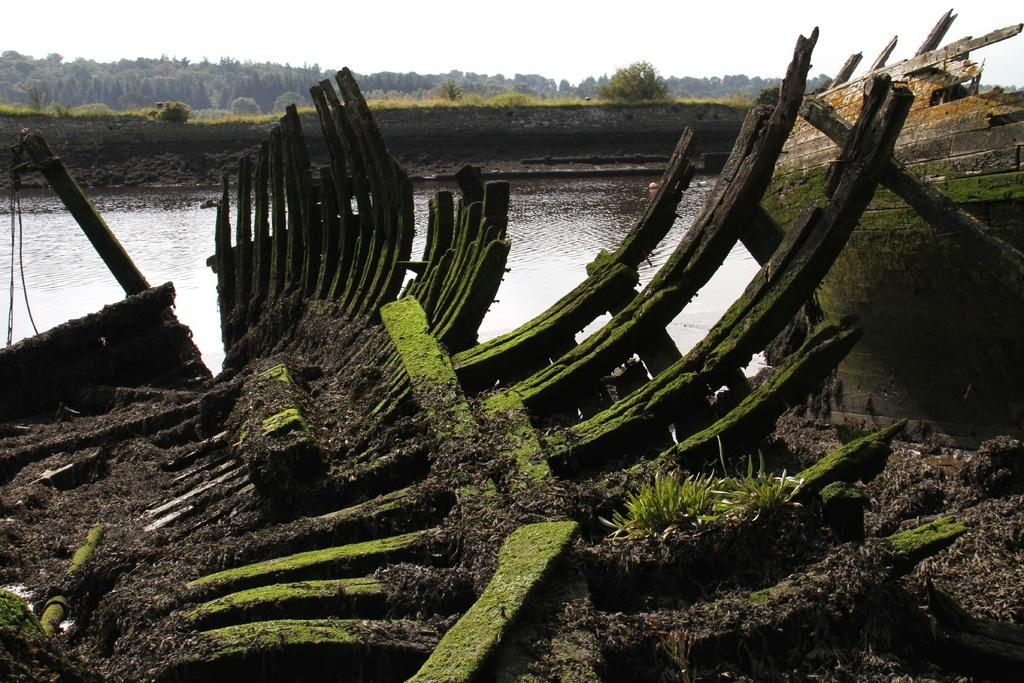What type of material is used for the objects in the image? The objects in the image are made of wood. What can be seen in the background of the image? The background of the image includes water, plants, trees, and the sky. What is present on the left side of the image? There are ropes on the left side of the image. What type of vegetation is visible in the image? There is grass in the image. What type of vacation is being advertised in the image? There is no indication of a vacation being advertised in the image; it simply features wooden objects, a background with water, plants, trees, and the sky, ropes, and grass. 